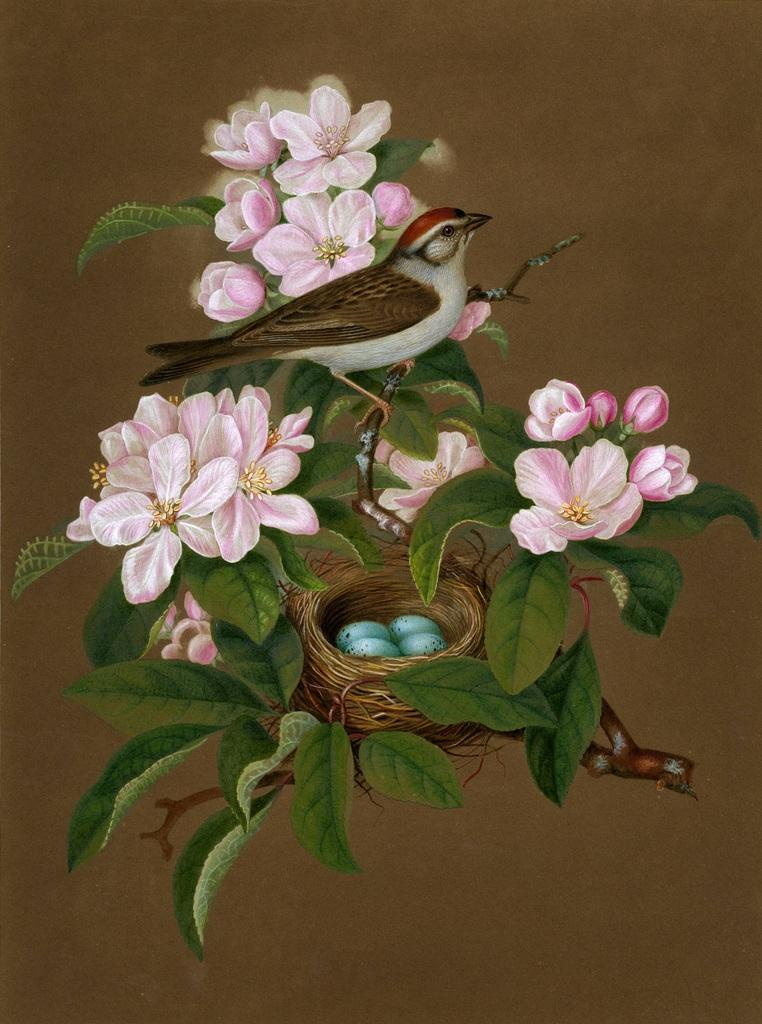What type of animal can be seen in the image? There is a bird in the image. Where is the bird located? The bird is on a branch in the image. What other elements can be seen in the image? There are flowers and a nest in the image. What is inside the nest? The nest contains eggs. What type of design can be seen on the farmer's umbrella in the image? There is no farmer or umbrella present in the image. 